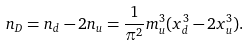<formula> <loc_0><loc_0><loc_500><loc_500>n _ { D } = n _ { d } - 2 n _ { u } = \frac { 1 } { \pi ^ { 2 } } m _ { u } ^ { 3 } ( x _ { d } ^ { 3 } - 2 x _ { u } ^ { 3 } ) .</formula> 